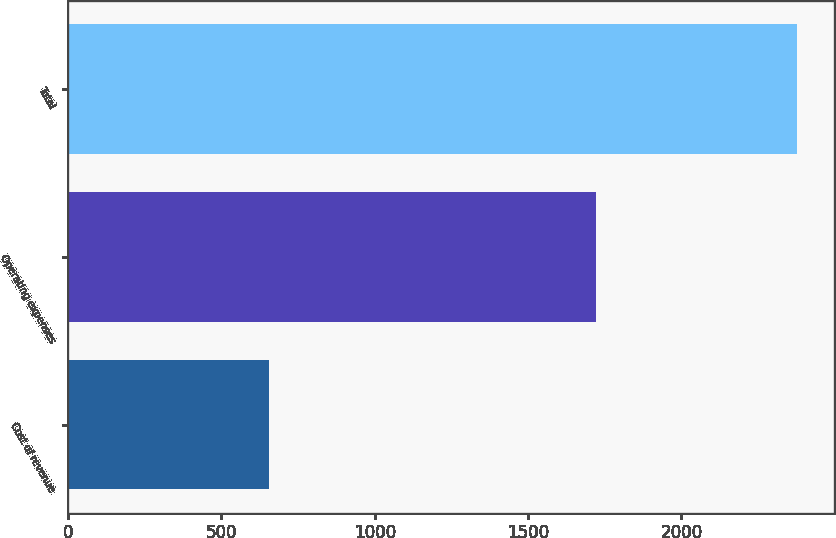<chart> <loc_0><loc_0><loc_500><loc_500><bar_chart><fcel>Cost of revenue<fcel>Operating expenses<fcel>Total<nl><fcel>654.2<fcel>1723.1<fcel>2377.3<nl></chart> 